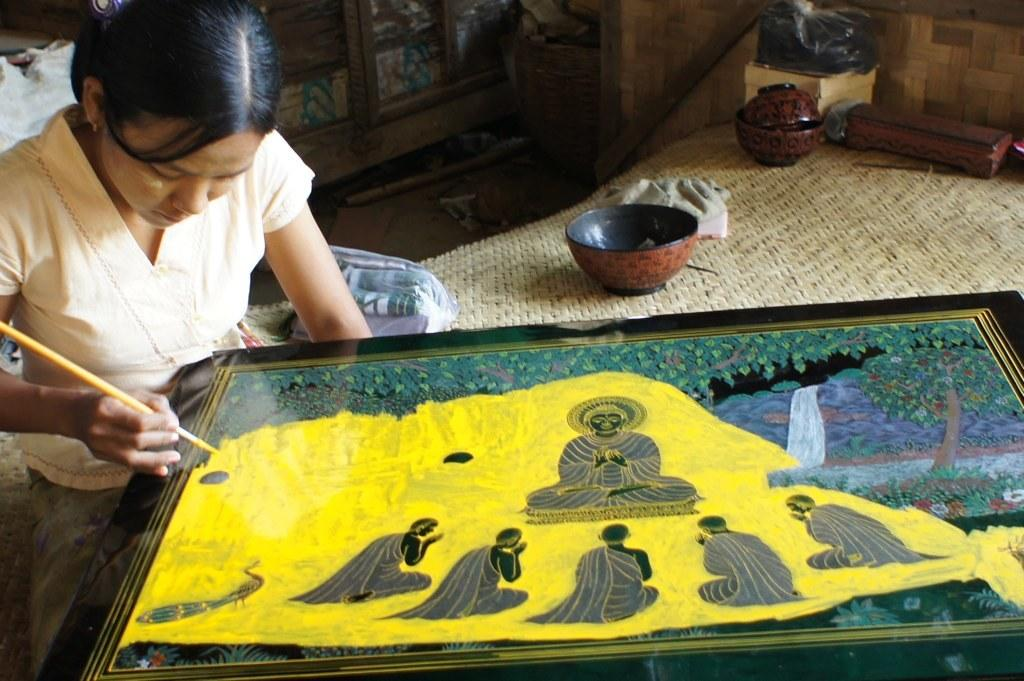What is the lady in the image doing? The lady in the image is painting. What objects can be seen in the image besides the lady? There are bowls, a cloth, a bag on a stand, and a cupboard in the background of the image. What is the purpose of the cloth in the image? The cloth's purpose is not explicitly mentioned, but it could be used for wiping brushes or protecting the surface the lady is painting on. What is the background of the image like? The background of the image includes a cupboard and a mat. How many chairs are visible in the image? There are no chairs visible in the image. Is there a rainstorm happening in the image? There is no indication of a rainstorm in the image. 